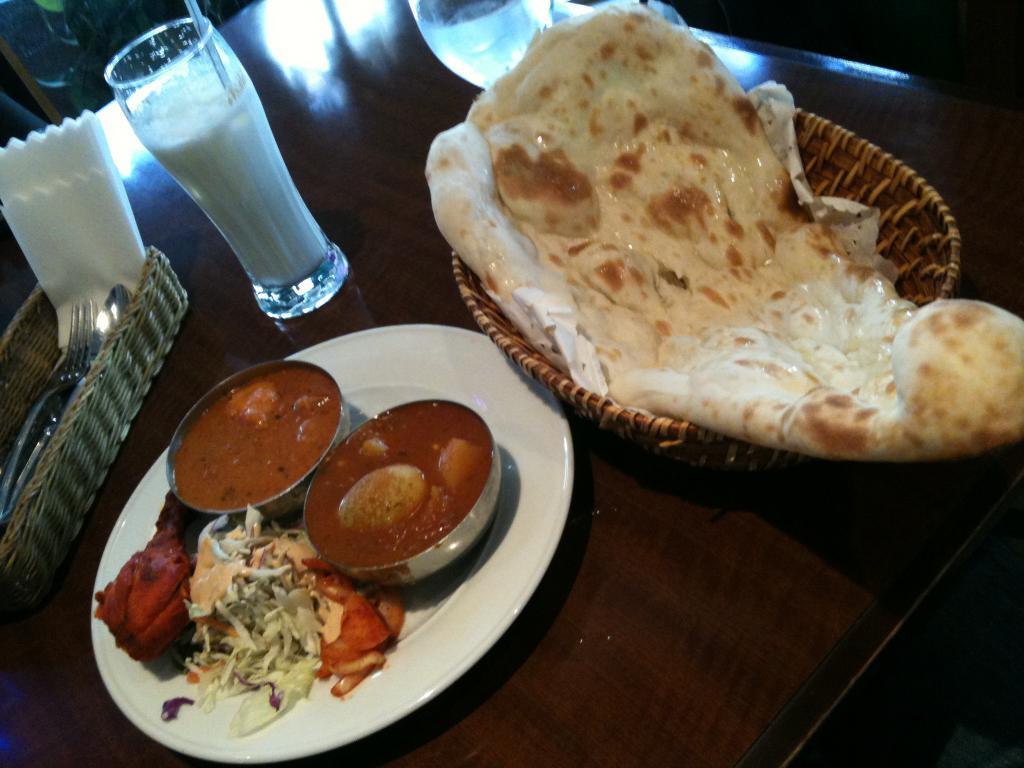Could you give a brief overview of what you see in this image? In this image we can see a roti in the basket, there is the food item in the plate, there are the glasses on the table. 